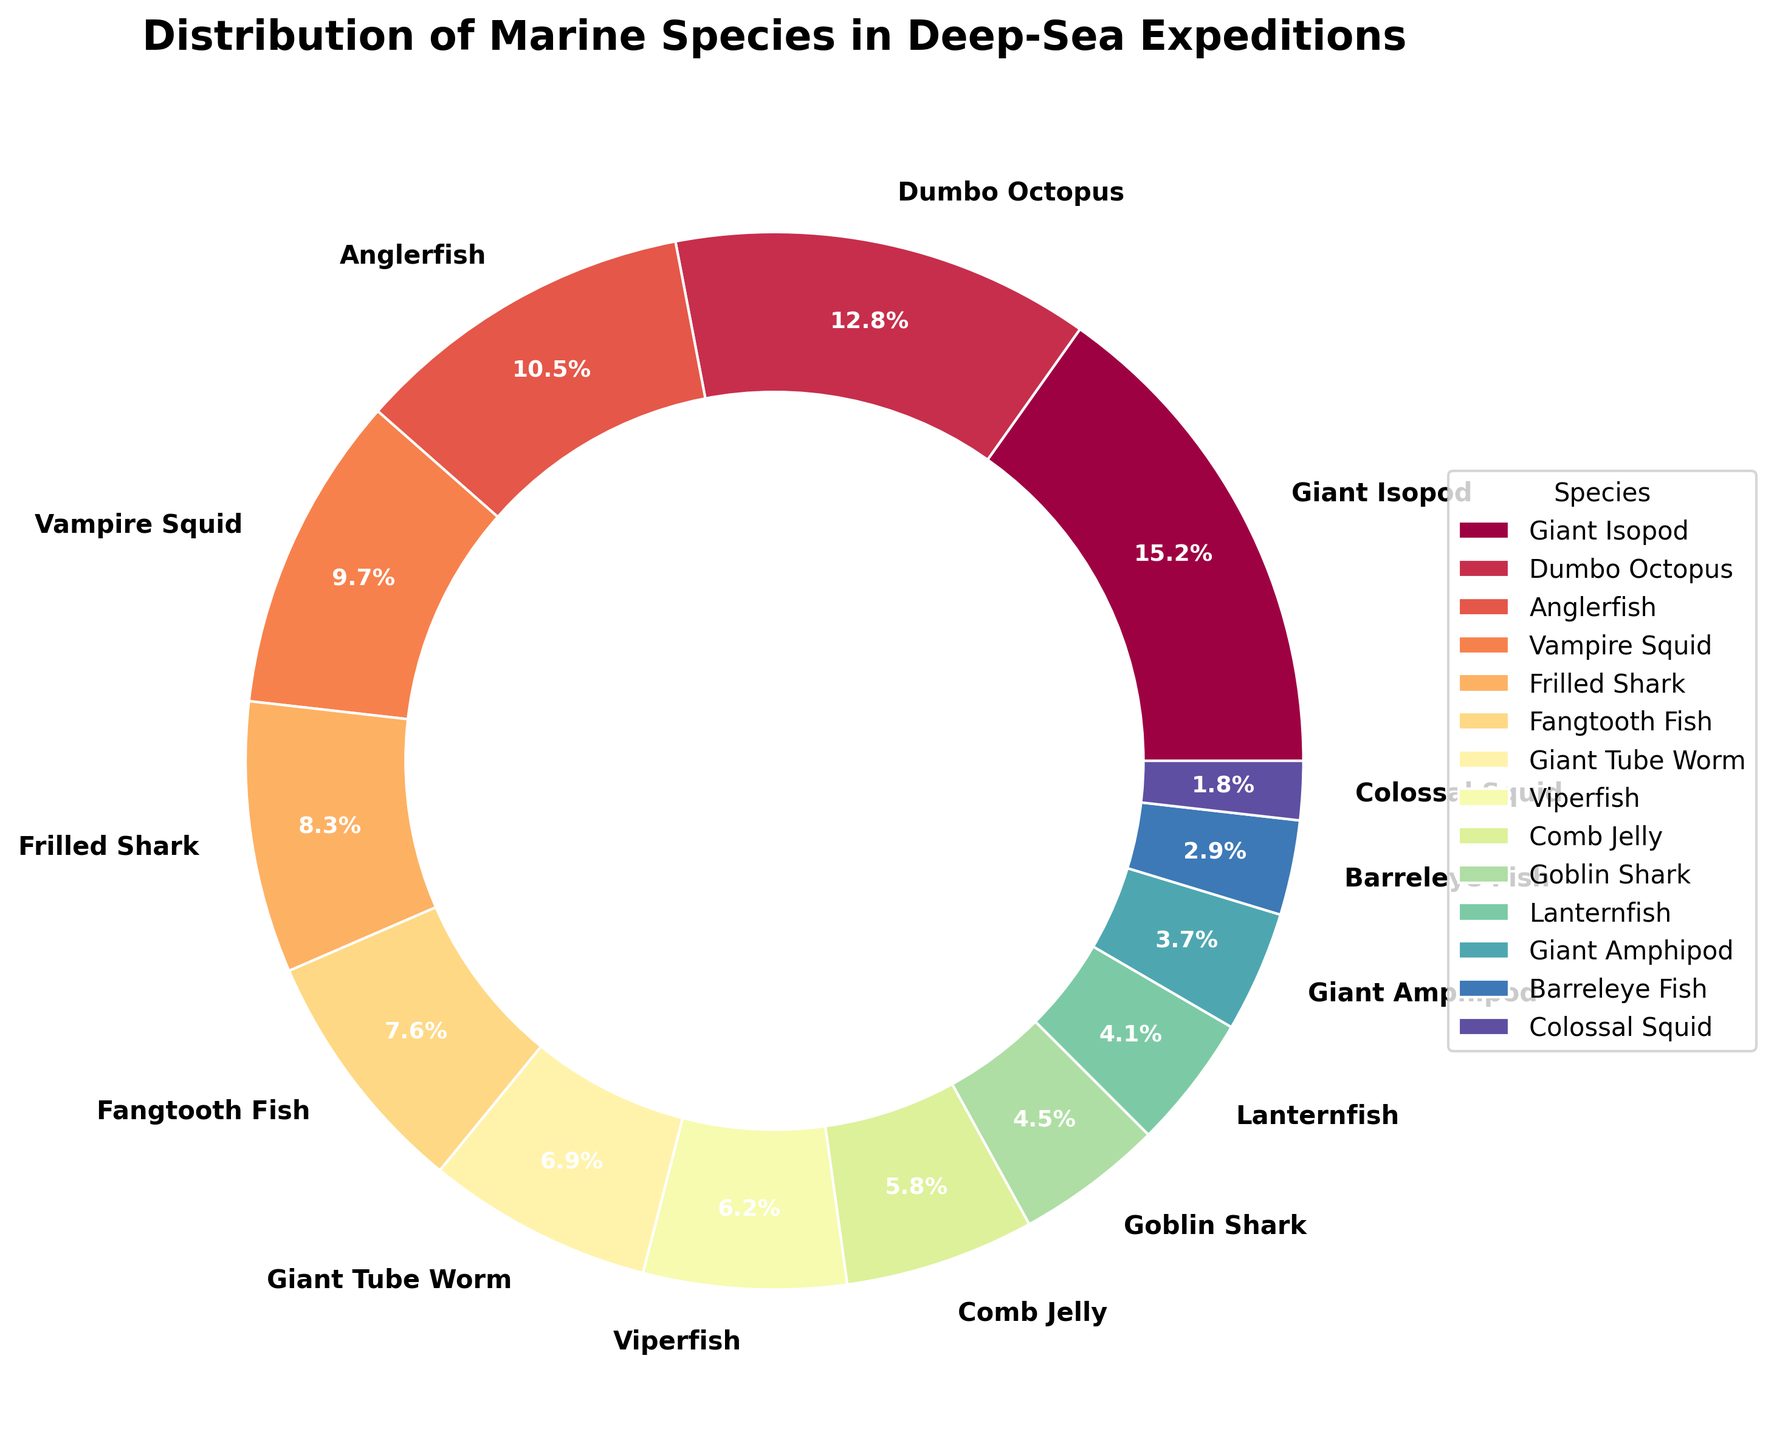what percentage of species collected accounts for giants (both Isopod and Amphipod)? We sum the percentages of Giant Isopod and Giant Amphipod. Giant Isopod is 15.2% and Giant Amphipod is 3.7%. Therefore, 15.2% + 3.7% = 18.9%.
Answer: 18.9% which species has the highest percentage? By looking at the figure, the species with the largest slice. The Giant Isopod slice appears the largest with 15.2%.
Answer: Giant Isopod which species has the smallest percentage? By identifying the smallest slice in the pie chart. The slice for the Colossal Squid is the smallest with 1.8%.
Answer: Colossal Squid which species percentages combined surpass the Dumbo Octopus percentage? We compare combinations of smaller percentages to see if they add up to more than 12.8%. Giant Tube Worm (6.9%) + Viperfish (6.2%) equals 13.1%, which is just over Dumbo Octopus.
Answer: Giant Tube Worm and Viperfish what is the difference in percentage between Anglerfish and Goblin Shark? We subtract the percentage of Goblin Shark from that of Anglerfish. Anglerfish is 10.5% and Goblin Shark is 4.5%. So, 10.5% - 4.5% = 6.0%.
Answer: 6.0% how many species have percentages lower than 5%? Count the slices in the pie chart that represent less than 5%. There are four species with less than 5%: Lanternfish (4.1%), Giant Amphipod (3.7%), Barreleye Fish (2.9%), and Colossal Squid (1.8%).
Answer: 4 which two species have percentages closest to each other? By comparing the differences in percentages between neighboring slices, the smallest difference is between Fangtooth Fish (7.6%) and Giant Tube Worm (6.9%), a difference of 0.7%.
Answer: Fangtooth Fish and Giant Tube Worm which species are more than twice the percentage of Lanternfish? Locate species with percentages more than twice that of Lanternfish (4.1%). Specifically, Giant Isopod (15.2%) and Dumbo Octopus (12.8%) both qualify, as their values are more than 8.2%.
Answer: Giant Isopod and Dumbo Octopus how much more percentage does the Viperfish have over the Vampire Squid? Subtract Vampire Squid's percentage from Viperfish. Viperfish (6.2%) - Vampire Squid (9.7%) = -3.5%, which means Vampire Squid actually has 3.5% more.
Answer: -3.5% 